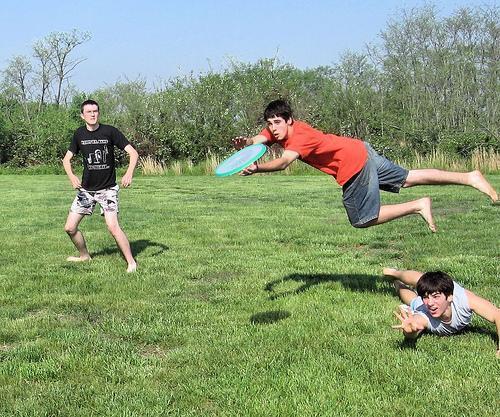How many people are shown?
Give a very brief answer. 3. How many frisbees are shown?
Give a very brief answer. 1. How many people are in the photo?
Give a very brief answer. 3. How many people can you see?
Give a very brief answer. 3. How many us airways express airplanes are in this image?
Give a very brief answer. 0. 